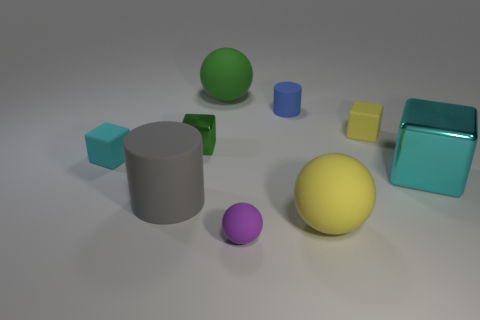Subtract all cyan cubes. How many were subtracted if there are1cyan cubes left? 1 Subtract all balls. How many objects are left? 6 Subtract 2 cylinders. How many cylinders are left? 0 Subtract all purple spheres. Subtract all gray blocks. How many spheres are left? 2 Subtract all blue cylinders. How many cyan blocks are left? 2 Subtract all yellow cubes. Subtract all matte cylinders. How many objects are left? 6 Add 6 purple things. How many purple things are left? 7 Add 3 small blue cylinders. How many small blue cylinders exist? 4 Add 1 yellow cylinders. How many objects exist? 10 Subtract all yellow spheres. How many spheres are left? 2 